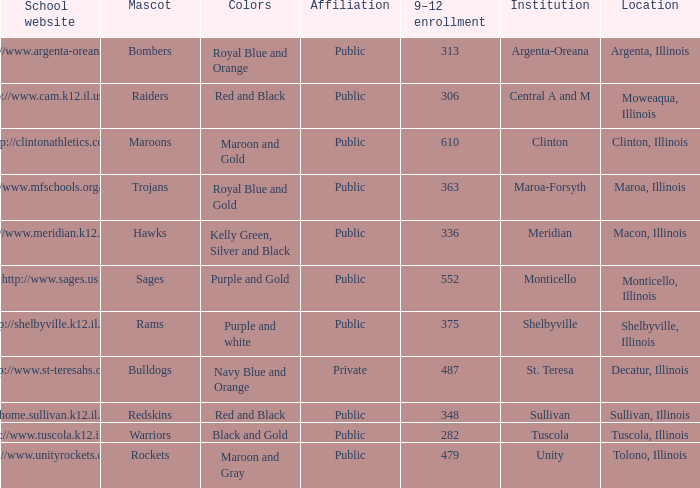What location has 363 students enrolled in the 9th to 12th grades? Maroa, Illinois. 